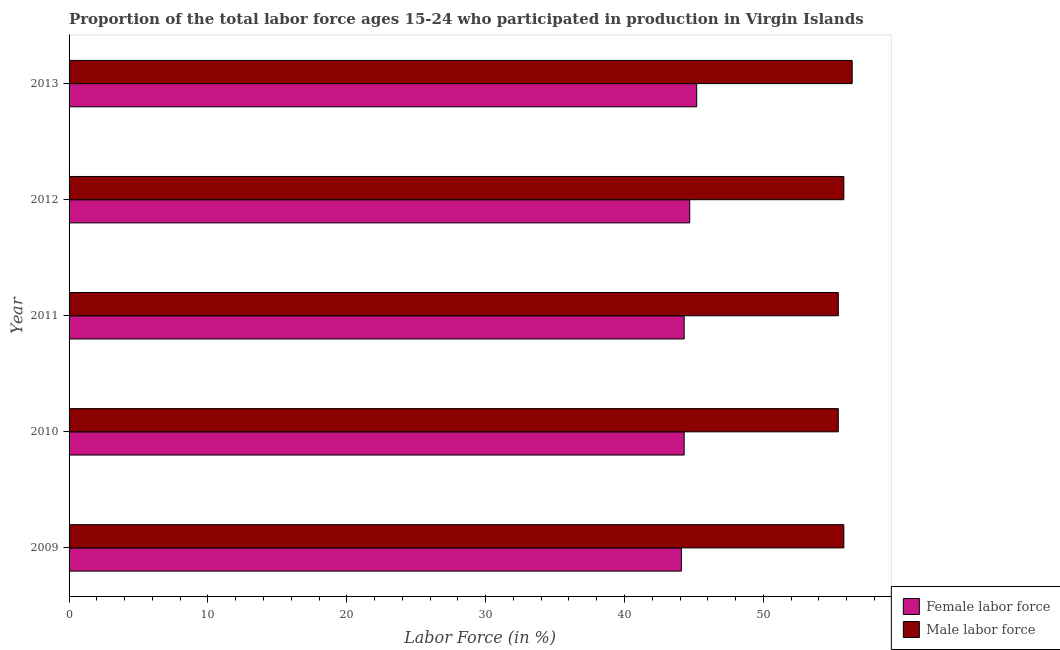How many different coloured bars are there?
Provide a short and direct response. 2. Are the number of bars per tick equal to the number of legend labels?
Offer a terse response. Yes. How many bars are there on the 5th tick from the top?
Your answer should be very brief. 2. How many bars are there on the 5th tick from the bottom?
Your answer should be very brief. 2. What is the label of the 2nd group of bars from the top?
Your response must be concise. 2012. What is the percentage of male labour force in 2011?
Provide a succinct answer. 55.4. Across all years, what is the maximum percentage of male labour force?
Provide a short and direct response. 56.4. Across all years, what is the minimum percentage of male labour force?
Your answer should be very brief. 55.4. In which year was the percentage of female labor force minimum?
Make the answer very short. 2009. What is the total percentage of female labor force in the graph?
Offer a terse response. 222.6. What is the difference between the percentage of female labor force in 2009 and that in 2012?
Make the answer very short. -0.6. What is the difference between the percentage of male labour force in 2010 and the percentage of female labor force in 2013?
Your answer should be compact. 10.2. What is the average percentage of male labour force per year?
Your response must be concise. 55.76. In the year 2012, what is the difference between the percentage of male labour force and percentage of female labor force?
Offer a very short reply. 11.1. What is the difference between the highest and the second highest percentage of female labor force?
Ensure brevity in your answer.  0.5. In how many years, is the percentage of male labour force greater than the average percentage of male labour force taken over all years?
Your response must be concise. 3. Is the sum of the percentage of male labour force in 2010 and 2011 greater than the maximum percentage of female labor force across all years?
Your answer should be compact. Yes. What does the 2nd bar from the top in 2010 represents?
Make the answer very short. Female labor force. What does the 1st bar from the bottom in 2011 represents?
Your answer should be compact. Female labor force. How many bars are there?
Make the answer very short. 10. Are all the bars in the graph horizontal?
Provide a short and direct response. Yes. What is the difference between two consecutive major ticks on the X-axis?
Ensure brevity in your answer.  10. Does the graph contain any zero values?
Make the answer very short. No. Does the graph contain grids?
Make the answer very short. No. How many legend labels are there?
Your answer should be compact. 2. How are the legend labels stacked?
Your response must be concise. Vertical. What is the title of the graph?
Ensure brevity in your answer.  Proportion of the total labor force ages 15-24 who participated in production in Virgin Islands. Does "Education" appear as one of the legend labels in the graph?
Your answer should be very brief. No. What is the Labor Force (in %) in Female labor force in 2009?
Your answer should be compact. 44.1. What is the Labor Force (in %) in Male labor force in 2009?
Ensure brevity in your answer.  55.8. What is the Labor Force (in %) in Female labor force in 2010?
Make the answer very short. 44.3. What is the Labor Force (in %) in Male labor force in 2010?
Give a very brief answer. 55.4. What is the Labor Force (in %) in Female labor force in 2011?
Your response must be concise. 44.3. What is the Labor Force (in %) of Male labor force in 2011?
Make the answer very short. 55.4. What is the Labor Force (in %) in Female labor force in 2012?
Offer a very short reply. 44.7. What is the Labor Force (in %) in Male labor force in 2012?
Make the answer very short. 55.8. What is the Labor Force (in %) in Female labor force in 2013?
Offer a terse response. 45.2. What is the Labor Force (in %) in Male labor force in 2013?
Ensure brevity in your answer.  56.4. Across all years, what is the maximum Labor Force (in %) in Female labor force?
Provide a succinct answer. 45.2. Across all years, what is the maximum Labor Force (in %) of Male labor force?
Your response must be concise. 56.4. Across all years, what is the minimum Labor Force (in %) in Female labor force?
Ensure brevity in your answer.  44.1. Across all years, what is the minimum Labor Force (in %) in Male labor force?
Your response must be concise. 55.4. What is the total Labor Force (in %) of Female labor force in the graph?
Provide a short and direct response. 222.6. What is the total Labor Force (in %) of Male labor force in the graph?
Make the answer very short. 278.8. What is the difference between the Labor Force (in %) of Female labor force in 2009 and that in 2010?
Make the answer very short. -0.2. What is the difference between the Labor Force (in %) of Male labor force in 2009 and that in 2011?
Keep it short and to the point. 0.4. What is the difference between the Labor Force (in %) of Female labor force in 2009 and that in 2013?
Provide a short and direct response. -1.1. What is the difference between the Labor Force (in %) in Male labor force in 2009 and that in 2013?
Your answer should be compact. -0.6. What is the difference between the Labor Force (in %) in Male labor force in 2010 and that in 2011?
Provide a short and direct response. 0. What is the difference between the Labor Force (in %) in Female labor force in 2010 and that in 2013?
Give a very brief answer. -0.9. What is the difference between the Labor Force (in %) in Male labor force in 2011 and that in 2012?
Provide a succinct answer. -0.4. What is the difference between the Labor Force (in %) of Female labor force in 2011 and that in 2013?
Offer a terse response. -0.9. What is the difference between the Labor Force (in %) in Male labor force in 2011 and that in 2013?
Provide a short and direct response. -1. What is the difference between the Labor Force (in %) of Male labor force in 2012 and that in 2013?
Make the answer very short. -0.6. What is the difference between the Labor Force (in %) of Female labor force in 2009 and the Labor Force (in %) of Male labor force in 2012?
Provide a succinct answer. -11.7. What is the difference between the Labor Force (in %) of Female labor force in 2010 and the Labor Force (in %) of Male labor force in 2012?
Offer a terse response. -11.5. What is the difference between the Labor Force (in %) in Female labor force in 2011 and the Labor Force (in %) in Male labor force in 2013?
Make the answer very short. -12.1. What is the average Labor Force (in %) of Female labor force per year?
Give a very brief answer. 44.52. What is the average Labor Force (in %) of Male labor force per year?
Your answer should be compact. 55.76. In the year 2009, what is the difference between the Labor Force (in %) in Female labor force and Labor Force (in %) in Male labor force?
Your answer should be very brief. -11.7. In the year 2010, what is the difference between the Labor Force (in %) of Female labor force and Labor Force (in %) of Male labor force?
Your answer should be very brief. -11.1. In the year 2012, what is the difference between the Labor Force (in %) in Female labor force and Labor Force (in %) in Male labor force?
Your answer should be very brief. -11.1. What is the ratio of the Labor Force (in %) of Female labor force in 2009 to that in 2010?
Offer a terse response. 1. What is the ratio of the Labor Force (in %) of Male labor force in 2009 to that in 2010?
Offer a very short reply. 1.01. What is the ratio of the Labor Force (in %) in Female labor force in 2009 to that in 2011?
Keep it short and to the point. 1. What is the ratio of the Labor Force (in %) of Female labor force in 2009 to that in 2012?
Give a very brief answer. 0.99. What is the ratio of the Labor Force (in %) of Male labor force in 2009 to that in 2012?
Your answer should be very brief. 1. What is the ratio of the Labor Force (in %) of Female labor force in 2009 to that in 2013?
Give a very brief answer. 0.98. What is the ratio of the Labor Force (in %) of Male labor force in 2010 to that in 2011?
Keep it short and to the point. 1. What is the ratio of the Labor Force (in %) of Female labor force in 2010 to that in 2012?
Offer a very short reply. 0.99. What is the ratio of the Labor Force (in %) in Male labor force in 2010 to that in 2012?
Give a very brief answer. 0.99. What is the ratio of the Labor Force (in %) in Female labor force in 2010 to that in 2013?
Offer a terse response. 0.98. What is the ratio of the Labor Force (in %) of Male labor force in 2010 to that in 2013?
Keep it short and to the point. 0.98. What is the ratio of the Labor Force (in %) in Female labor force in 2011 to that in 2013?
Your answer should be compact. 0.98. What is the ratio of the Labor Force (in %) in Male labor force in 2011 to that in 2013?
Make the answer very short. 0.98. What is the ratio of the Labor Force (in %) in Female labor force in 2012 to that in 2013?
Offer a terse response. 0.99. What is the difference between the highest and the second highest Labor Force (in %) in Male labor force?
Keep it short and to the point. 0.6. What is the difference between the highest and the lowest Labor Force (in %) of Male labor force?
Offer a very short reply. 1. 